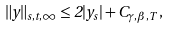Convert formula to latex. <formula><loc_0><loc_0><loc_500><loc_500>\| y \| _ { s , t , \infty } \leq 2 | y _ { s } | + C _ { { \gamma } , { \beta } , T } \, ,</formula> 